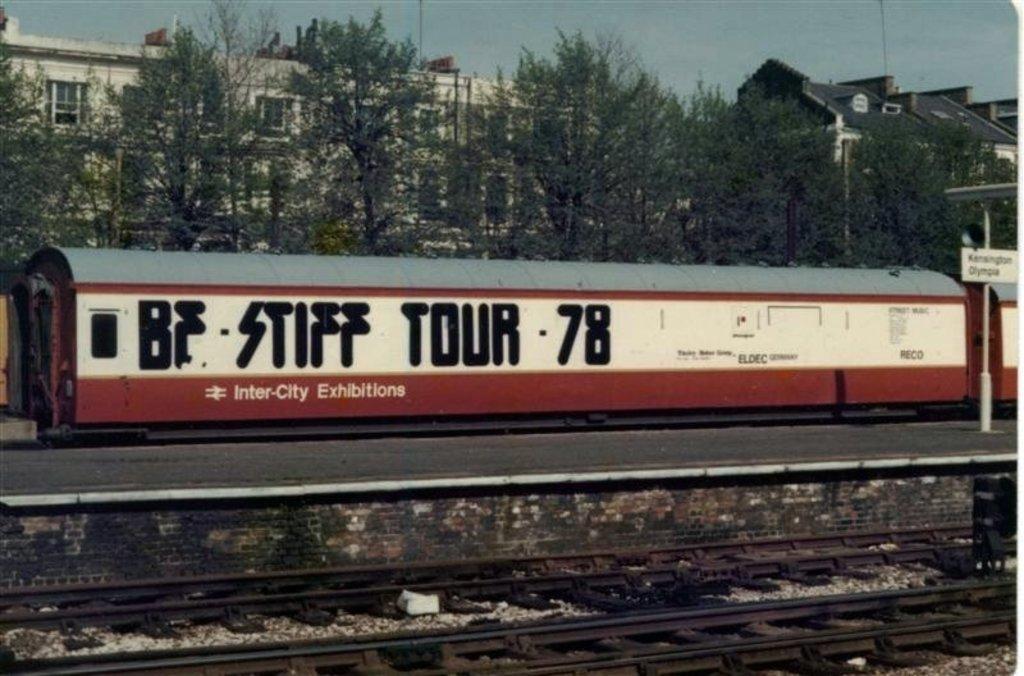Describe this image in one or two sentences. In the foreground we can see railway track, stones, platform, name board and other objects. In the middle of the picture there are trees, train, buildings and other object. At the top it is sky. 